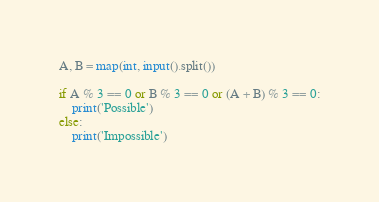Convert code to text. <code><loc_0><loc_0><loc_500><loc_500><_Python_>A, B = map(int, input().split())

if A % 3 == 0 or B % 3 == 0 or (A + B) % 3 == 0:
    print('Possible')
else:
    print('Impossible')
</code> 